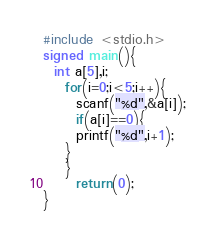<code> <loc_0><loc_0><loc_500><loc_500><_C_>#include <stdio.h>
signed main(){
  int a[5],i;
    for(i=0;i<5;i++){
      scanf("%d",&a[i]);
      if(a[i]==0){
      printf("%d",i+1);
    }
    }
      return(0);
}</code> 